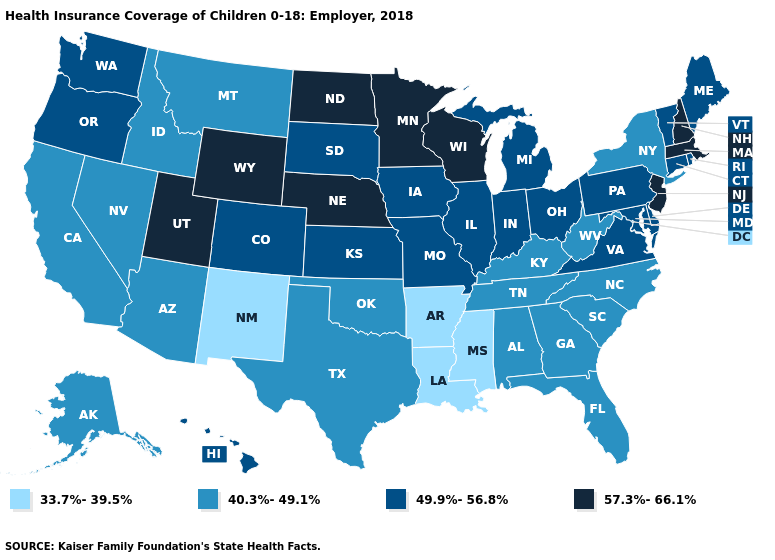What is the value of South Carolina?
Concise answer only. 40.3%-49.1%. Name the states that have a value in the range 40.3%-49.1%?
Answer briefly. Alabama, Alaska, Arizona, California, Florida, Georgia, Idaho, Kentucky, Montana, Nevada, New York, North Carolina, Oklahoma, South Carolina, Tennessee, Texas, West Virginia. What is the value of New Mexico?
Quick response, please. 33.7%-39.5%. Name the states that have a value in the range 40.3%-49.1%?
Quick response, please. Alabama, Alaska, Arizona, California, Florida, Georgia, Idaho, Kentucky, Montana, Nevada, New York, North Carolina, Oklahoma, South Carolina, Tennessee, Texas, West Virginia. Which states hav the highest value in the West?
Write a very short answer. Utah, Wyoming. What is the value of Massachusetts?
Be succinct. 57.3%-66.1%. Name the states that have a value in the range 57.3%-66.1%?
Quick response, please. Massachusetts, Minnesota, Nebraska, New Hampshire, New Jersey, North Dakota, Utah, Wisconsin, Wyoming. What is the value of Tennessee?
Write a very short answer. 40.3%-49.1%. Which states have the highest value in the USA?
Give a very brief answer. Massachusetts, Minnesota, Nebraska, New Hampshire, New Jersey, North Dakota, Utah, Wisconsin, Wyoming. Does the first symbol in the legend represent the smallest category?
Give a very brief answer. Yes. Which states have the highest value in the USA?
Quick response, please. Massachusetts, Minnesota, Nebraska, New Hampshire, New Jersey, North Dakota, Utah, Wisconsin, Wyoming. What is the value of Florida?
Answer briefly. 40.3%-49.1%. Name the states that have a value in the range 40.3%-49.1%?
Answer briefly. Alabama, Alaska, Arizona, California, Florida, Georgia, Idaho, Kentucky, Montana, Nevada, New York, North Carolina, Oklahoma, South Carolina, Tennessee, Texas, West Virginia. Does New Mexico have the lowest value in the USA?
Short answer required. Yes. What is the lowest value in the MidWest?
Keep it brief. 49.9%-56.8%. 